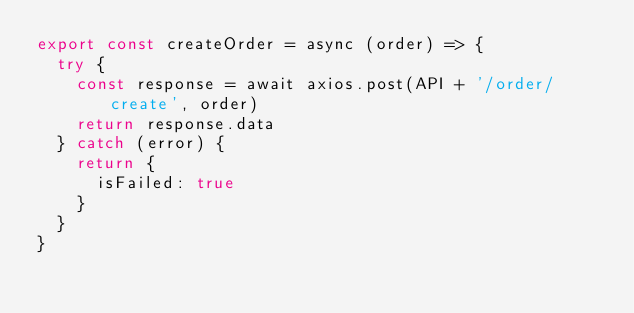Convert code to text. <code><loc_0><loc_0><loc_500><loc_500><_JavaScript_>export const createOrder = async (order) => {
	try {
		const response = await axios.post(API + '/order/create', order)
		return response.data
	} catch (error) {
		return {
			isFailed: true
		}
	}
}</code> 